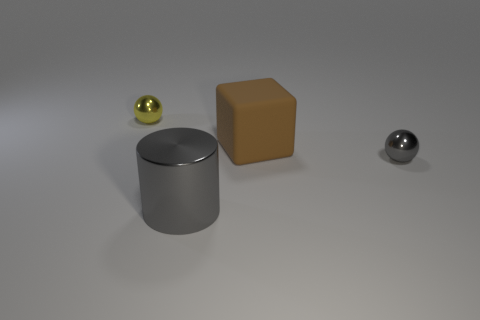Add 1 brown things. How many objects exist? 5 Subtract all cylinders. How many objects are left? 3 Add 2 large cylinders. How many large cylinders are left? 3 Add 4 yellow spheres. How many yellow spheres exist? 5 Subtract 0 gray blocks. How many objects are left? 4 Subtract all big cyan matte cubes. Subtract all shiny things. How many objects are left? 1 